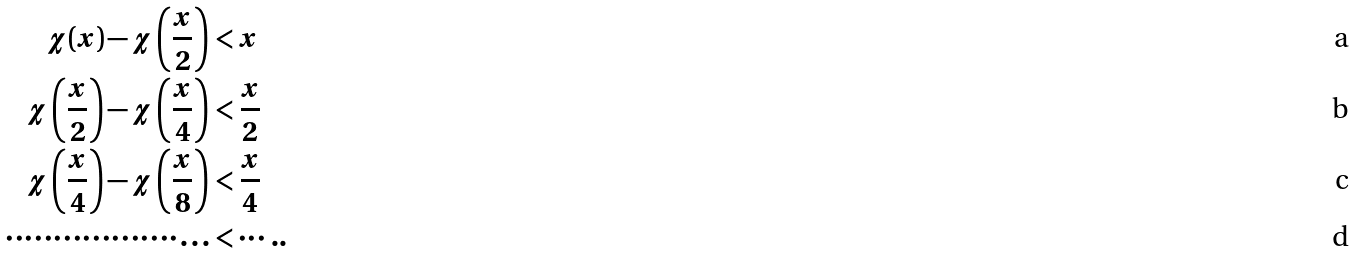Convert formula to latex. <formula><loc_0><loc_0><loc_500><loc_500>\chi ( x ) - \chi \left ( \frac { x } { 2 } \right ) & < x \\ \chi \left ( \frac { x } { 2 } \right ) - \chi \left ( \frac { x } { 4 } \right ) & < \frac { x } { 2 } \\ \chi \left ( \frac { x } { 4 } \right ) - \chi \left ( \frac { x } { 8 } \right ) & < \frac { x } { 4 } \\ \cdots \cdots \cdots \cdots \cdots \cdots \dots & < \cdots . .</formula> 